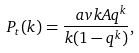<formula> <loc_0><loc_0><loc_500><loc_500>P _ { t } ( k ) = \frac { \ a v k A q ^ { k } } { k ( 1 - q ^ { k } ) } ,</formula> 